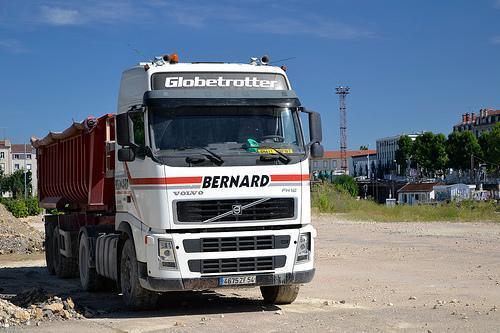How many trucks are in the photo?
Give a very brief answer. 1. 